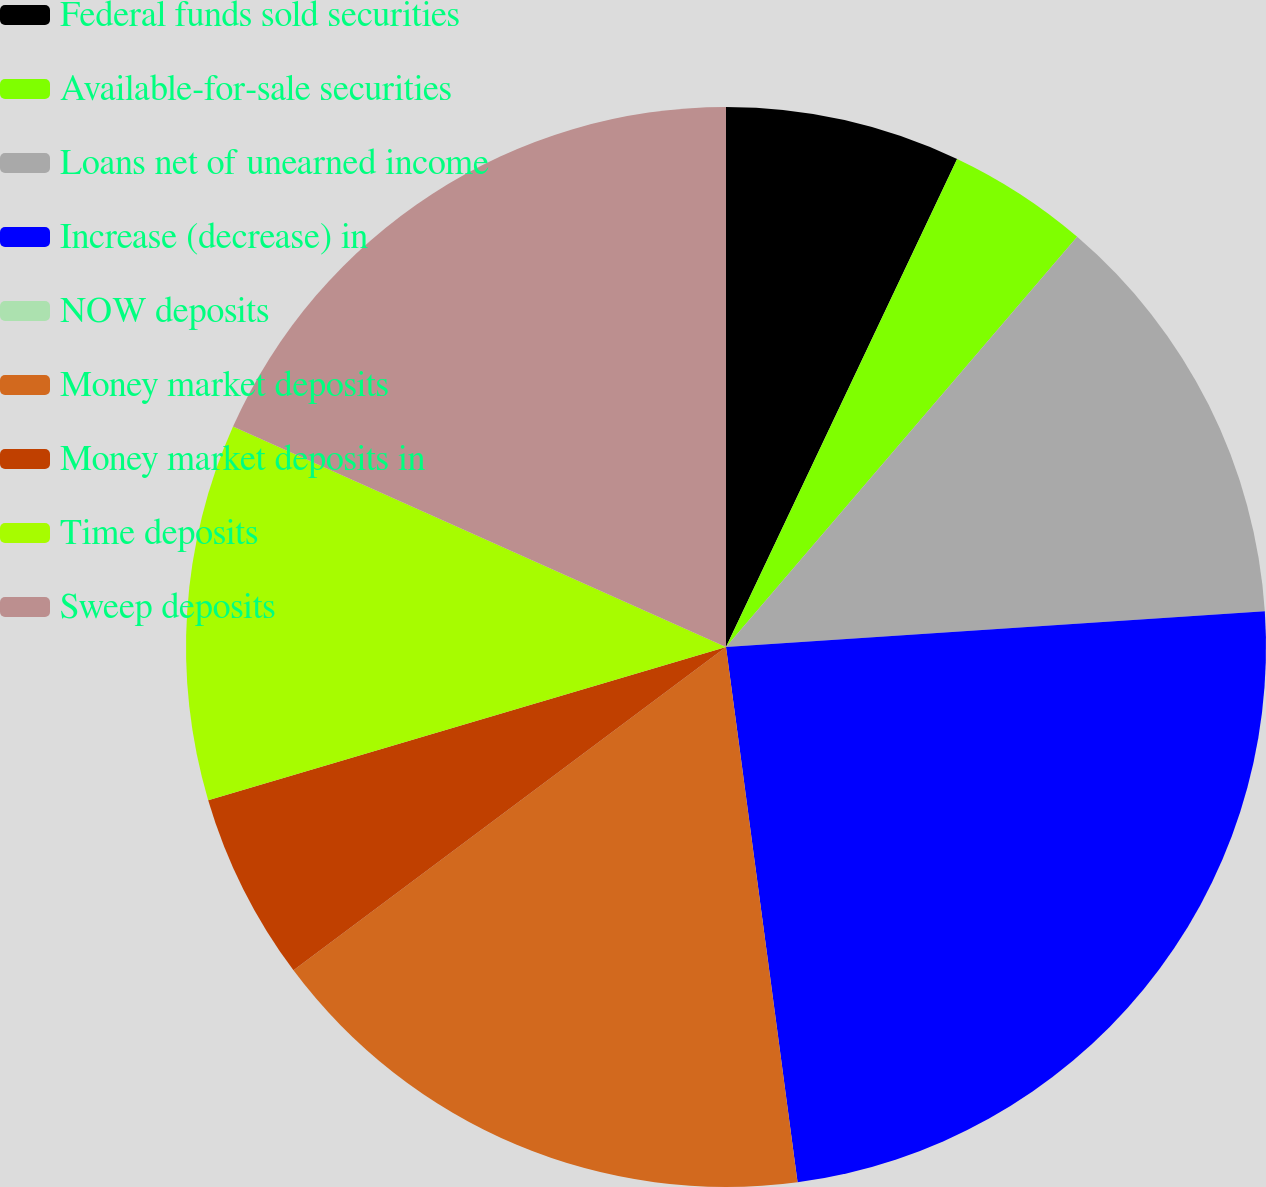Convert chart. <chart><loc_0><loc_0><loc_500><loc_500><pie_chart><fcel>Federal funds sold securities<fcel>Available-for-sale securities<fcel>Loans net of unearned income<fcel>Increase (decrease) in<fcel>NOW deposits<fcel>Money market deposits<fcel>Money market deposits in<fcel>Time deposits<fcel>Sweep deposits<nl><fcel>7.04%<fcel>4.23%<fcel>12.68%<fcel>23.94%<fcel>0.0%<fcel>16.9%<fcel>5.64%<fcel>11.27%<fcel>18.31%<nl></chart> 